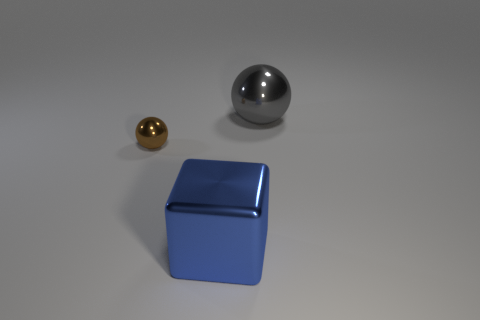There is a object behind the small brown metal ball; does it have the same color as the big thing that is to the left of the gray object?
Give a very brief answer. No. What number of other things are made of the same material as the large gray thing?
Provide a short and direct response. 2. The metal thing that is both on the right side of the brown object and left of the large gray thing has what shape?
Make the answer very short. Cube. There is a tiny metallic object; does it have the same color as the metal sphere right of the big blue cube?
Give a very brief answer. No. Is the size of the object that is behind the brown shiny thing the same as the tiny brown sphere?
Ensure brevity in your answer.  No. There is another gray thing that is the same shape as the small metallic object; what is it made of?
Make the answer very short. Metal. Does the tiny object have the same shape as the blue object?
Provide a short and direct response. No. What number of objects are behind the metal sphere that is to the left of the blue block?
Provide a succinct answer. 1. There is a big gray thing that is the same material as the blue object; what shape is it?
Your response must be concise. Sphere. How many brown things are tiny objects or big metal objects?
Provide a succinct answer. 1. 